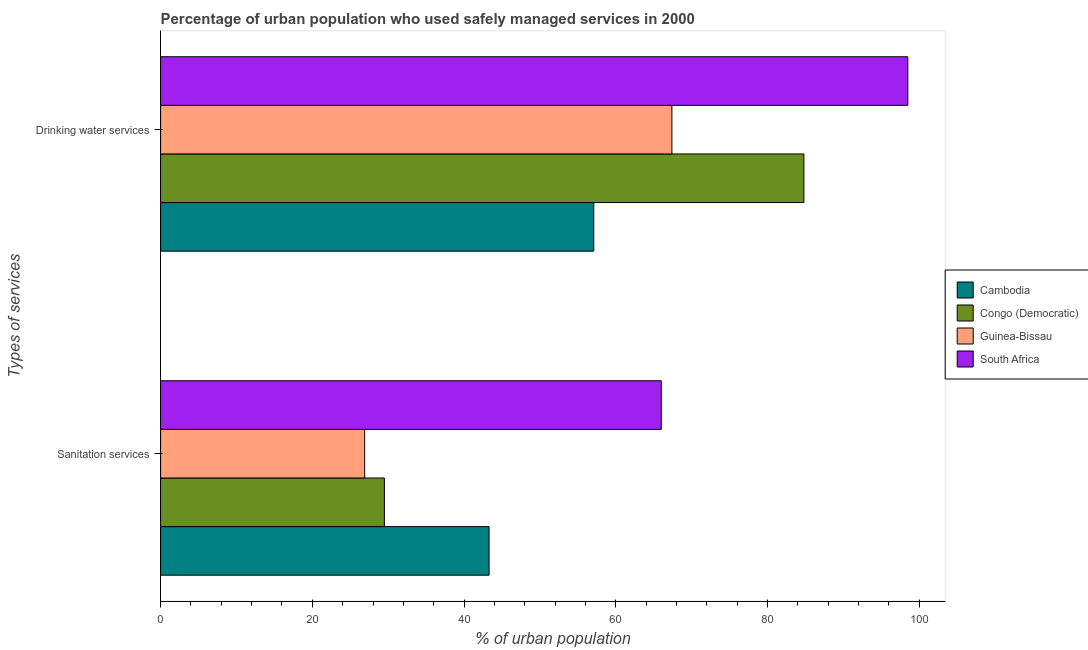How many different coloured bars are there?
Offer a terse response. 4. Are the number of bars per tick equal to the number of legend labels?
Your response must be concise. Yes. Are the number of bars on each tick of the Y-axis equal?
Offer a very short reply. Yes. How many bars are there on the 1st tick from the bottom?
Keep it short and to the point. 4. What is the label of the 1st group of bars from the top?
Make the answer very short. Drinking water services. Across all countries, what is the minimum percentage of urban population who used sanitation services?
Make the answer very short. 26.9. In which country was the percentage of urban population who used drinking water services maximum?
Ensure brevity in your answer.  South Africa. In which country was the percentage of urban population who used drinking water services minimum?
Provide a short and direct response. Cambodia. What is the total percentage of urban population who used drinking water services in the graph?
Ensure brevity in your answer.  307.8. What is the difference between the percentage of urban population who used sanitation services in South Africa and that in Cambodia?
Provide a short and direct response. 22.7. What is the difference between the percentage of urban population who used drinking water services in Cambodia and the percentage of urban population who used sanitation services in South Africa?
Provide a succinct answer. -8.9. What is the average percentage of urban population who used sanitation services per country?
Your answer should be compact. 41.42. What is the difference between the percentage of urban population who used drinking water services and percentage of urban population who used sanitation services in Cambodia?
Your response must be concise. 13.8. In how many countries, is the percentage of urban population who used sanitation services greater than 80 %?
Keep it short and to the point. 0. What is the ratio of the percentage of urban population who used sanitation services in Congo (Democratic) to that in Cambodia?
Your answer should be very brief. 0.68. In how many countries, is the percentage of urban population who used sanitation services greater than the average percentage of urban population who used sanitation services taken over all countries?
Give a very brief answer. 2. What does the 2nd bar from the top in Sanitation services represents?
Your answer should be very brief. Guinea-Bissau. What does the 2nd bar from the bottom in Drinking water services represents?
Your answer should be compact. Congo (Democratic). How many countries are there in the graph?
Offer a terse response. 4. What is the difference between two consecutive major ticks on the X-axis?
Ensure brevity in your answer.  20. What is the title of the graph?
Ensure brevity in your answer.  Percentage of urban population who used safely managed services in 2000. What is the label or title of the X-axis?
Your answer should be very brief. % of urban population. What is the label or title of the Y-axis?
Make the answer very short. Types of services. What is the % of urban population of Cambodia in Sanitation services?
Your answer should be very brief. 43.3. What is the % of urban population of Congo (Democratic) in Sanitation services?
Your answer should be very brief. 29.5. What is the % of urban population in Guinea-Bissau in Sanitation services?
Ensure brevity in your answer.  26.9. What is the % of urban population in Cambodia in Drinking water services?
Provide a succinct answer. 57.1. What is the % of urban population of Congo (Democratic) in Drinking water services?
Your response must be concise. 84.8. What is the % of urban population of Guinea-Bissau in Drinking water services?
Make the answer very short. 67.4. What is the % of urban population in South Africa in Drinking water services?
Provide a succinct answer. 98.5. Across all Types of services, what is the maximum % of urban population of Cambodia?
Your answer should be compact. 57.1. Across all Types of services, what is the maximum % of urban population in Congo (Democratic)?
Your answer should be compact. 84.8. Across all Types of services, what is the maximum % of urban population in Guinea-Bissau?
Keep it short and to the point. 67.4. Across all Types of services, what is the maximum % of urban population in South Africa?
Make the answer very short. 98.5. Across all Types of services, what is the minimum % of urban population in Cambodia?
Your answer should be compact. 43.3. Across all Types of services, what is the minimum % of urban population of Congo (Democratic)?
Provide a short and direct response. 29.5. Across all Types of services, what is the minimum % of urban population in Guinea-Bissau?
Make the answer very short. 26.9. Across all Types of services, what is the minimum % of urban population in South Africa?
Your answer should be compact. 66. What is the total % of urban population in Cambodia in the graph?
Your response must be concise. 100.4. What is the total % of urban population in Congo (Democratic) in the graph?
Make the answer very short. 114.3. What is the total % of urban population in Guinea-Bissau in the graph?
Your answer should be compact. 94.3. What is the total % of urban population of South Africa in the graph?
Make the answer very short. 164.5. What is the difference between the % of urban population in Cambodia in Sanitation services and that in Drinking water services?
Give a very brief answer. -13.8. What is the difference between the % of urban population of Congo (Democratic) in Sanitation services and that in Drinking water services?
Your answer should be very brief. -55.3. What is the difference between the % of urban population of Guinea-Bissau in Sanitation services and that in Drinking water services?
Give a very brief answer. -40.5. What is the difference between the % of urban population in South Africa in Sanitation services and that in Drinking water services?
Your answer should be compact. -32.5. What is the difference between the % of urban population of Cambodia in Sanitation services and the % of urban population of Congo (Democratic) in Drinking water services?
Make the answer very short. -41.5. What is the difference between the % of urban population in Cambodia in Sanitation services and the % of urban population in Guinea-Bissau in Drinking water services?
Keep it short and to the point. -24.1. What is the difference between the % of urban population in Cambodia in Sanitation services and the % of urban population in South Africa in Drinking water services?
Your answer should be compact. -55.2. What is the difference between the % of urban population in Congo (Democratic) in Sanitation services and the % of urban population in Guinea-Bissau in Drinking water services?
Make the answer very short. -37.9. What is the difference between the % of urban population of Congo (Democratic) in Sanitation services and the % of urban population of South Africa in Drinking water services?
Make the answer very short. -69. What is the difference between the % of urban population of Guinea-Bissau in Sanitation services and the % of urban population of South Africa in Drinking water services?
Offer a very short reply. -71.6. What is the average % of urban population of Cambodia per Types of services?
Make the answer very short. 50.2. What is the average % of urban population of Congo (Democratic) per Types of services?
Your response must be concise. 57.15. What is the average % of urban population in Guinea-Bissau per Types of services?
Your answer should be compact. 47.15. What is the average % of urban population in South Africa per Types of services?
Make the answer very short. 82.25. What is the difference between the % of urban population of Cambodia and % of urban population of South Africa in Sanitation services?
Provide a succinct answer. -22.7. What is the difference between the % of urban population in Congo (Democratic) and % of urban population in Guinea-Bissau in Sanitation services?
Keep it short and to the point. 2.6. What is the difference between the % of urban population of Congo (Democratic) and % of urban population of South Africa in Sanitation services?
Keep it short and to the point. -36.5. What is the difference between the % of urban population of Guinea-Bissau and % of urban population of South Africa in Sanitation services?
Offer a terse response. -39.1. What is the difference between the % of urban population of Cambodia and % of urban population of Congo (Democratic) in Drinking water services?
Ensure brevity in your answer.  -27.7. What is the difference between the % of urban population in Cambodia and % of urban population in South Africa in Drinking water services?
Your response must be concise. -41.4. What is the difference between the % of urban population of Congo (Democratic) and % of urban population of Guinea-Bissau in Drinking water services?
Your response must be concise. 17.4. What is the difference between the % of urban population of Congo (Democratic) and % of urban population of South Africa in Drinking water services?
Make the answer very short. -13.7. What is the difference between the % of urban population in Guinea-Bissau and % of urban population in South Africa in Drinking water services?
Keep it short and to the point. -31.1. What is the ratio of the % of urban population in Cambodia in Sanitation services to that in Drinking water services?
Your response must be concise. 0.76. What is the ratio of the % of urban population in Congo (Democratic) in Sanitation services to that in Drinking water services?
Provide a succinct answer. 0.35. What is the ratio of the % of urban population of Guinea-Bissau in Sanitation services to that in Drinking water services?
Your answer should be very brief. 0.4. What is the ratio of the % of urban population of South Africa in Sanitation services to that in Drinking water services?
Ensure brevity in your answer.  0.67. What is the difference between the highest and the second highest % of urban population in Congo (Democratic)?
Make the answer very short. 55.3. What is the difference between the highest and the second highest % of urban population of Guinea-Bissau?
Your answer should be very brief. 40.5. What is the difference between the highest and the second highest % of urban population in South Africa?
Provide a succinct answer. 32.5. What is the difference between the highest and the lowest % of urban population in Congo (Democratic)?
Keep it short and to the point. 55.3. What is the difference between the highest and the lowest % of urban population of Guinea-Bissau?
Give a very brief answer. 40.5. What is the difference between the highest and the lowest % of urban population in South Africa?
Make the answer very short. 32.5. 